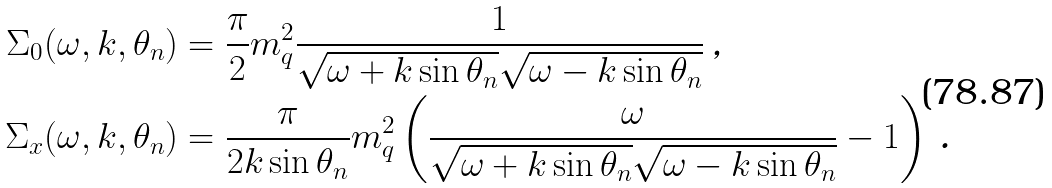<formula> <loc_0><loc_0><loc_500><loc_500>\Sigma _ { 0 } ( \omega , k , \theta _ { n } ) & = \frac { \pi } { 2 } m _ { q } ^ { 2 } \frac { 1 } { \sqrt { \omega + k \sin \theta _ { n } } \sqrt { \omega - k \sin \theta _ { n } } } \, \text {,} \\ \Sigma _ { x } ( \omega , k , \theta _ { n } ) & = \frac { \pi } { 2 k \sin \theta _ { n } } m _ { q } ^ { 2 } \left ( \frac { \omega } { \sqrt { \omega + k \sin \theta _ { n } } \sqrt { \omega - k \sin \theta _ { n } } } - 1 \right ) \, \text {.}</formula> 